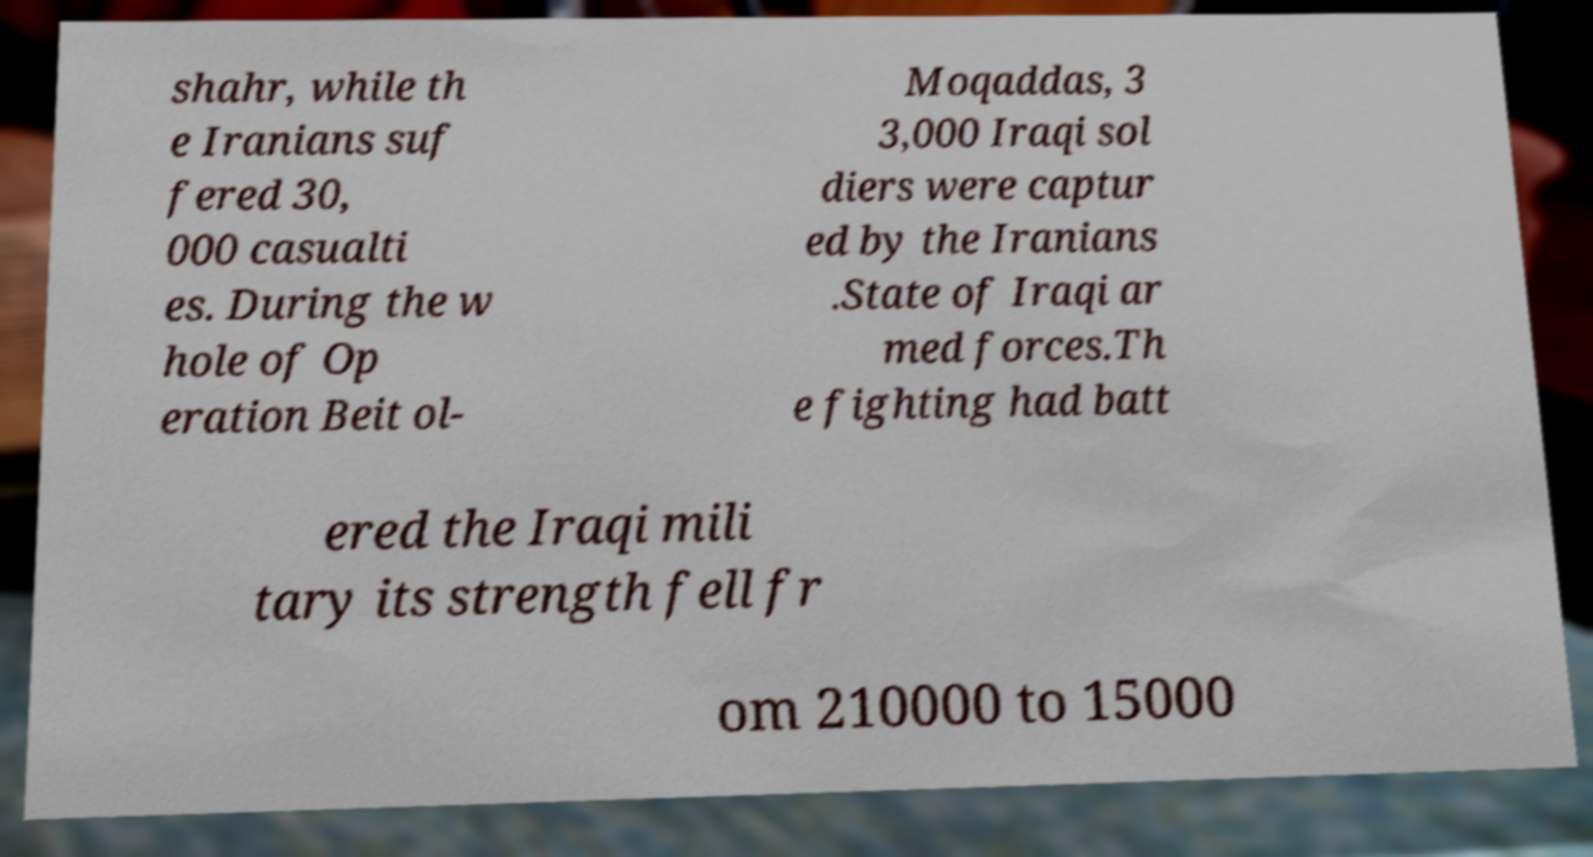Can you read and provide the text displayed in the image?This photo seems to have some interesting text. Can you extract and type it out for me? shahr, while th e Iranians suf fered 30, 000 casualti es. During the w hole of Op eration Beit ol- Moqaddas, 3 3,000 Iraqi sol diers were captur ed by the Iranians .State of Iraqi ar med forces.Th e fighting had batt ered the Iraqi mili tary its strength fell fr om 210000 to 15000 